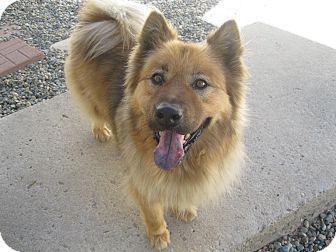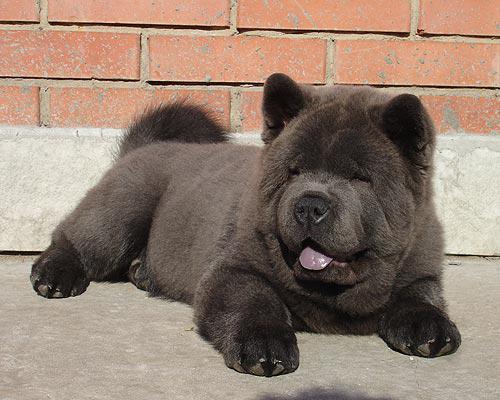The first image is the image on the left, the second image is the image on the right. Given the left and right images, does the statement "The left and right image contains the same number of dogs one dark brown and the other light brown." hold true? Answer yes or no. Yes. 